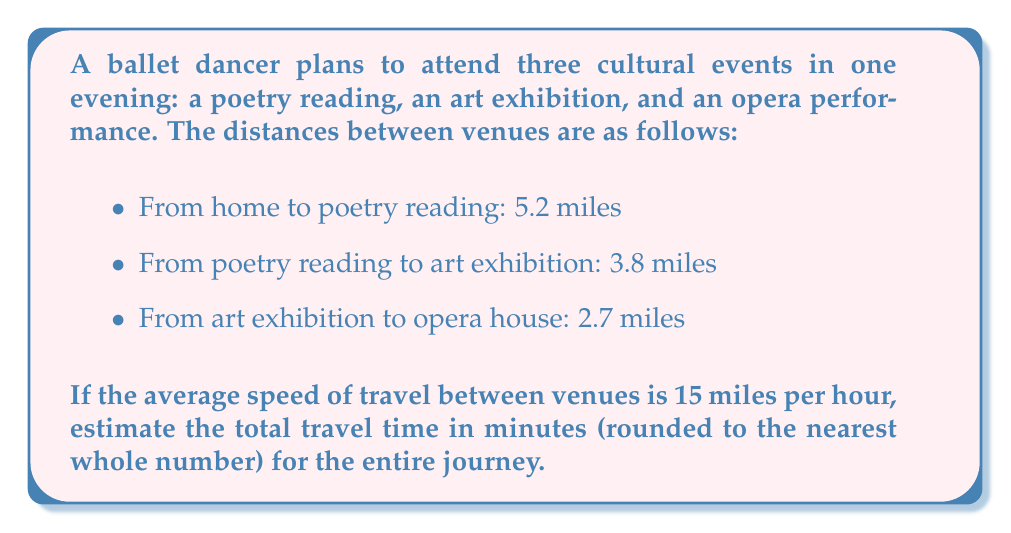Can you answer this question? Let's approach this problem step-by-step:

1. Calculate the total distance:
   $$ \text{Total distance} = 5.2 + 3.8 + 2.7 = 11.7 \text{ miles} $$

2. Use the rate formula to find the time:
   $$ \text{Time} = \frac{\text{Distance}}{\text{Rate}} $$

3. Plug in the values:
   $$ \text{Time} = \frac{11.7 \text{ miles}}{15 \text{ miles/hour}} $$

4. Perform the division:
   $$ \text{Time} = 0.78 \text{ hours} $$

5. Convert hours to minutes:
   $$ 0.78 \text{ hours} \times 60 \text{ minutes/hour} = 46.8 \text{ minutes} $$

6. Round to the nearest whole number:
   $$ 46.8 \text{ minutes} \approx 47 \text{ minutes} $$

Therefore, the estimated total travel time is 47 minutes.
Answer: 47 minutes 